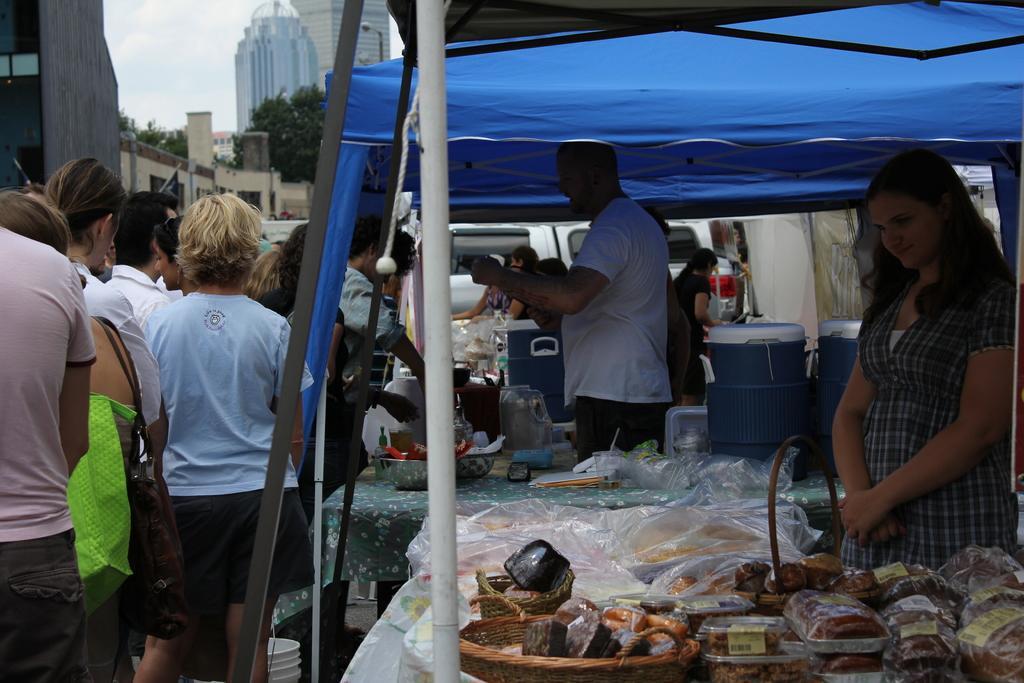How would you summarize this image in a sentence or two? In this image there are a few people behind a table and there are many objects on it, in front of them there is a group of people and in the background there are buildings and vehicles. 